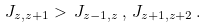<formula> <loc_0><loc_0><loc_500><loc_500>J _ { z , z + 1 } > \, J _ { z - 1 , z } \, , \, J _ { z + 1 , z + 2 } \, .</formula> 